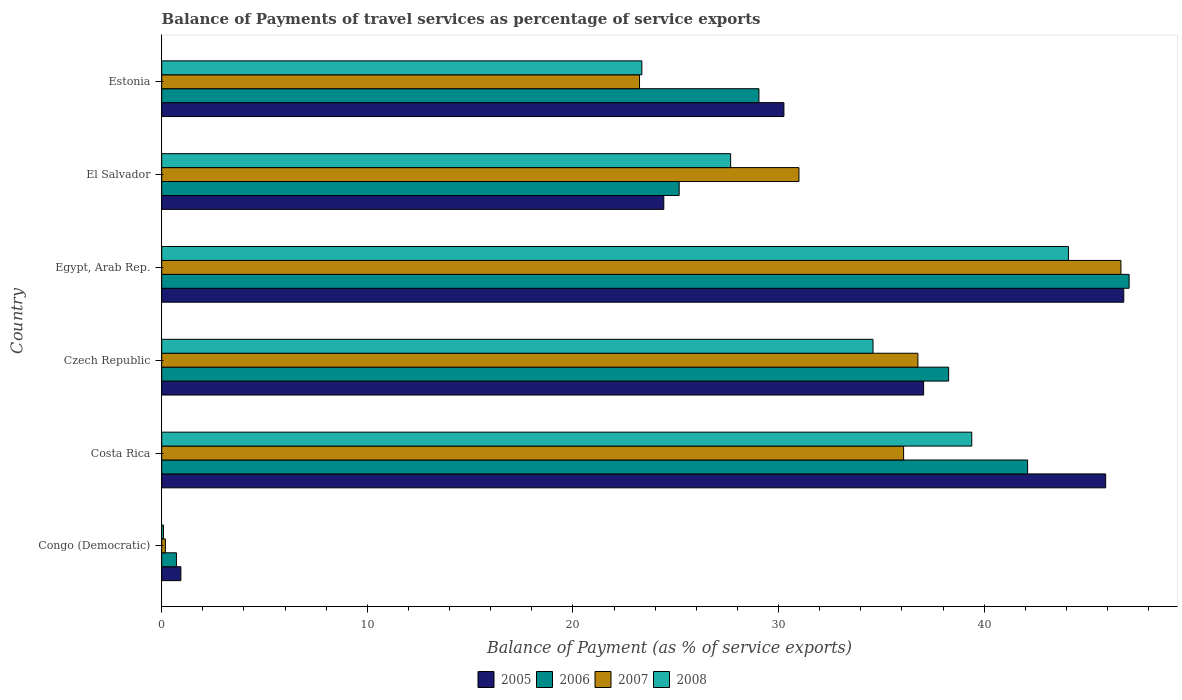How many groups of bars are there?
Provide a short and direct response. 6. Are the number of bars on each tick of the Y-axis equal?
Offer a very short reply. Yes. How many bars are there on the 2nd tick from the bottom?
Provide a succinct answer. 4. What is the label of the 2nd group of bars from the top?
Ensure brevity in your answer.  El Salvador. In how many cases, is the number of bars for a given country not equal to the number of legend labels?
Offer a terse response. 0. What is the balance of payments of travel services in 2006 in El Salvador?
Offer a very short reply. 25.17. Across all countries, what is the maximum balance of payments of travel services in 2006?
Give a very brief answer. 47.05. Across all countries, what is the minimum balance of payments of travel services in 2006?
Provide a short and direct response. 0.72. In which country was the balance of payments of travel services in 2005 maximum?
Make the answer very short. Egypt, Arab Rep. In which country was the balance of payments of travel services in 2008 minimum?
Keep it short and to the point. Congo (Democratic). What is the total balance of payments of travel services in 2005 in the graph?
Keep it short and to the point. 185.35. What is the difference between the balance of payments of travel services in 2005 in Czech Republic and that in Egypt, Arab Rep.?
Ensure brevity in your answer.  -9.73. What is the difference between the balance of payments of travel services in 2006 in Czech Republic and the balance of payments of travel services in 2008 in Congo (Democratic)?
Make the answer very short. 38.18. What is the average balance of payments of travel services in 2008 per country?
Provide a succinct answer. 28.2. What is the difference between the balance of payments of travel services in 2008 and balance of payments of travel services in 2005 in Costa Rica?
Give a very brief answer. -6.51. What is the ratio of the balance of payments of travel services in 2005 in Czech Republic to that in El Salvador?
Your answer should be compact. 1.52. Is the balance of payments of travel services in 2007 in Congo (Democratic) less than that in Czech Republic?
Your response must be concise. Yes. Is the difference between the balance of payments of travel services in 2008 in Congo (Democratic) and Egypt, Arab Rep. greater than the difference between the balance of payments of travel services in 2005 in Congo (Democratic) and Egypt, Arab Rep.?
Ensure brevity in your answer.  Yes. What is the difference between the highest and the second highest balance of payments of travel services in 2008?
Your answer should be compact. 4.7. What is the difference between the highest and the lowest balance of payments of travel services in 2008?
Your answer should be very brief. 44.01. Is it the case that in every country, the sum of the balance of payments of travel services in 2006 and balance of payments of travel services in 2007 is greater than the balance of payments of travel services in 2005?
Your answer should be very brief. No. How many countries are there in the graph?
Keep it short and to the point. 6. What is the difference between two consecutive major ticks on the X-axis?
Offer a very short reply. 10. Are the values on the major ticks of X-axis written in scientific E-notation?
Provide a succinct answer. No. Does the graph contain any zero values?
Make the answer very short. No. What is the title of the graph?
Ensure brevity in your answer.  Balance of Payments of travel services as percentage of service exports. Does "1972" appear as one of the legend labels in the graph?
Provide a succinct answer. No. What is the label or title of the X-axis?
Offer a very short reply. Balance of Payment (as % of service exports). What is the label or title of the Y-axis?
Ensure brevity in your answer.  Country. What is the Balance of Payment (as % of service exports) in 2005 in Congo (Democratic)?
Offer a very short reply. 0.93. What is the Balance of Payment (as % of service exports) in 2006 in Congo (Democratic)?
Your response must be concise. 0.72. What is the Balance of Payment (as % of service exports) in 2007 in Congo (Democratic)?
Your answer should be very brief. 0.18. What is the Balance of Payment (as % of service exports) of 2008 in Congo (Democratic)?
Provide a short and direct response. 0.08. What is the Balance of Payment (as % of service exports) in 2005 in Costa Rica?
Your answer should be compact. 45.91. What is the Balance of Payment (as % of service exports) in 2006 in Costa Rica?
Your answer should be compact. 42.11. What is the Balance of Payment (as % of service exports) of 2007 in Costa Rica?
Offer a terse response. 36.08. What is the Balance of Payment (as % of service exports) of 2008 in Costa Rica?
Give a very brief answer. 39.39. What is the Balance of Payment (as % of service exports) in 2005 in Czech Republic?
Offer a very short reply. 37.05. What is the Balance of Payment (as % of service exports) of 2006 in Czech Republic?
Offer a terse response. 38.27. What is the Balance of Payment (as % of service exports) of 2007 in Czech Republic?
Your answer should be very brief. 36.77. What is the Balance of Payment (as % of service exports) of 2008 in Czech Republic?
Provide a succinct answer. 34.59. What is the Balance of Payment (as % of service exports) of 2005 in Egypt, Arab Rep.?
Provide a succinct answer. 46.79. What is the Balance of Payment (as % of service exports) in 2006 in Egypt, Arab Rep.?
Your answer should be compact. 47.05. What is the Balance of Payment (as % of service exports) of 2007 in Egypt, Arab Rep.?
Give a very brief answer. 46.65. What is the Balance of Payment (as % of service exports) of 2008 in Egypt, Arab Rep.?
Your response must be concise. 44.09. What is the Balance of Payment (as % of service exports) in 2005 in El Salvador?
Offer a terse response. 24.42. What is the Balance of Payment (as % of service exports) of 2006 in El Salvador?
Offer a very short reply. 25.17. What is the Balance of Payment (as % of service exports) in 2007 in El Salvador?
Your answer should be compact. 30.99. What is the Balance of Payment (as % of service exports) in 2008 in El Salvador?
Your answer should be compact. 27.67. What is the Balance of Payment (as % of service exports) of 2005 in Estonia?
Give a very brief answer. 30.26. What is the Balance of Payment (as % of service exports) of 2006 in Estonia?
Give a very brief answer. 29.04. What is the Balance of Payment (as % of service exports) in 2007 in Estonia?
Your response must be concise. 23.24. What is the Balance of Payment (as % of service exports) in 2008 in Estonia?
Make the answer very short. 23.35. Across all countries, what is the maximum Balance of Payment (as % of service exports) of 2005?
Offer a very short reply. 46.79. Across all countries, what is the maximum Balance of Payment (as % of service exports) in 2006?
Your response must be concise. 47.05. Across all countries, what is the maximum Balance of Payment (as % of service exports) in 2007?
Make the answer very short. 46.65. Across all countries, what is the maximum Balance of Payment (as % of service exports) of 2008?
Keep it short and to the point. 44.09. Across all countries, what is the minimum Balance of Payment (as % of service exports) of 2005?
Give a very brief answer. 0.93. Across all countries, what is the minimum Balance of Payment (as % of service exports) in 2006?
Offer a very short reply. 0.72. Across all countries, what is the minimum Balance of Payment (as % of service exports) of 2007?
Provide a succinct answer. 0.18. Across all countries, what is the minimum Balance of Payment (as % of service exports) of 2008?
Provide a succinct answer. 0.08. What is the total Balance of Payment (as % of service exports) in 2005 in the graph?
Ensure brevity in your answer.  185.35. What is the total Balance of Payment (as % of service exports) of 2006 in the graph?
Keep it short and to the point. 182.35. What is the total Balance of Payment (as % of service exports) in 2007 in the graph?
Keep it short and to the point. 173.91. What is the total Balance of Payment (as % of service exports) of 2008 in the graph?
Offer a terse response. 169.18. What is the difference between the Balance of Payment (as % of service exports) in 2005 in Congo (Democratic) and that in Costa Rica?
Ensure brevity in your answer.  -44.97. What is the difference between the Balance of Payment (as % of service exports) of 2006 in Congo (Democratic) and that in Costa Rica?
Provide a succinct answer. -41.4. What is the difference between the Balance of Payment (as % of service exports) in 2007 in Congo (Democratic) and that in Costa Rica?
Ensure brevity in your answer.  -35.9. What is the difference between the Balance of Payment (as % of service exports) in 2008 in Congo (Democratic) and that in Costa Rica?
Ensure brevity in your answer.  -39.31. What is the difference between the Balance of Payment (as % of service exports) in 2005 in Congo (Democratic) and that in Czech Republic?
Your response must be concise. -36.12. What is the difference between the Balance of Payment (as % of service exports) of 2006 in Congo (Democratic) and that in Czech Republic?
Your response must be concise. -37.55. What is the difference between the Balance of Payment (as % of service exports) in 2007 in Congo (Democratic) and that in Czech Republic?
Provide a succinct answer. -36.6. What is the difference between the Balance of Payment (as % of service exports) in 2008 in Congo (Democratic) and that in Czech Republic?
Offer a terse response. -34.51. What is the difference between the Balance of Payment (as % of service exports) in 2005 in Congo (Democratic) and that in Egypt, Arab Rep.?
Offer a very short reply. -45.85. What is the difference between the Balance of Payment (as % of service exports) in 2006 in Congo (Democratic) and that in Egypt, Arab Rep.?
Make the answer very short. -46.33. What is the difference between the Balance of Payment (as % of service exports) in 2007 in Congo (Democratic) and that in Egypt, Arab Rep.?
Ensure brevity in your answer.  -46.47. What is the difference between the Balance of Payment (as % of service exports) in 2008 in Congo (Democratic) and that in Egypt, Arab Rep.?
Provide a succinct answer. -44.01. What is the difference between the Balance of Payment (as % of service exports) of 2005 in Congo (Democratic) and that in El Salvador?
Ensure brevity in your answer.  -23.49. What is the difference between the Balance of Payment (as % of service exports) in 2006 in Congo (Democratic) and that in El Salvador?
Offer a very short reply. -24.45. What is the difference between the Balance of Payment (as % of service exports) of 2007 in Congo (Democratic) and that in El Salvador?
Ensure brevity in your answer.  -30.81. What is the difference between the Balance of Payment (as % of service exports) in 2008 in Congo (Democratic) and that in El Salvador?
Offer a terse response. -27.58. What is the difference between the Balance of Payment (as % of service exports) in 2005 in Congo (Democratic) and that in Estonia?
Give a very brief answer. -29.33. What is the difference between the Balance of Payment (as % of service exports) in 2006 in Congo (Democratic) and that in Estonia?
Offer a very short reply. -28.33. What is the difference between the Balance of Payment (as % of service exports) of 2007 in Congo (Democratic) and that in Estonia?
Give a very brief answer. -23.06. What is the difference between the Balance of Payment (as % of service exports) in 2008 in Congo (Democratic) and that in Estonia?
Make the answer very short. -23.27. What is the difference between the Balance of Payment (as % of service exports) in 2005 in Costa Rica and that in Czech Republic?
Your answer should be compact. 8.85. What is the difference between the Balance of Payment (as % of service exports) in 2006 in Costa Rica and that in Czech Republic?
Your answer should be very brief. 3.84. What is the difference between the Balance of Payment (as % of service exports) in 2007 in Costa Rica and that in Czech Republic?
Ensure brevity in your answer.  -0.69. What is the difference between the Balance of Payment (as % of service exports) of 2008 in Costa Rica and that in Czech Republic?
Offer a terse response. 4.8. What is the difference between the Balance of Payment (as % of service exports) of 2005 in Costa Rica and that in Egypt, Arab Rep.?
Your answer should be compact. -0.88. What is the difference between the Balance of Payment (as % of service exports) in 2006 in Costa Rica and that in Egypt, Arab Rep.?
Provide a short and direct response. -4.94. What is the difference between the Balance of Payment (as % of service exports) of 2007 in Costa Rica and that in Egypt, Arab Rep.?
Make the answer very short. -10.57. What is the difference between the Balance of Payment (as % of service exports) of 2008 in Costa Rica and that in Egypt, Arab Rep.?
Provide a succinct answer. -4.7. What is the difference between the Balance of Payment (as % of service exports) of 2005 in Costa Rica and that in El Salvador?
Make the answer very short. 21.49. What is the difference between the Balance of Payment (as % of service exports) in 2006 in Costa Rica and that in El Salvador?
Provide a succinct answer. 16.95. What is the difference between the Balance of Payment (as % of service exports) in 2007 in Costa Rica and that in El Salvador?
Your answer should be compact. 5.09. What is the difference between the Balance of Payment (as % of service exports) in 2008 in Costa Rica and that in El Salvador?
Give a very brief answer. 11.73. What is the difference between the Balance of Payment (as % of service exports) of 2005 in Costa Rica and that in Estonia?
Your answer should be very brief. 15.65. What is the difference between the Balance of Payment (as % of service exports) of 2006 in Costa Rica and that in Estonia?
Provide a succinct answer. 13.07. What is the difference between the Balance of Payment (as % of service exports) in 2007 in Costa Rica and that in Estonia?
Offer a very short reply. 12.84. What is the difference between the Balance of Payment (as % of service exports) in 2008 in Costa Rica and that in Estonia?
Your response must be concise. 16.04. What is the difference between the Balance of Payment (as % of service exports) of 2005 in Czech Republic and that in Egypt, Arab Rep.?
Your answer should be very brief. -9.73. What is the difference between the Balance of Payment (as % of service exports) of 2006 in Czech Republic and that in Egypt, Arab Rep.?
Give a very brief answer. -8.78. What is the difference between the Balance of Payment (as % of service exports) in 2007 in Czech Republic and that in Egypt, Arab Rep.?
Make the answer very short. -9.87. What is the difference between the Balance of Payment (as % of service exports) in 2008 in Czech Republic and that in Egypt, Arab Rep.?
Your answer should be very brief. -9.5. What is the difference between the Balance of Payment (as % of service exports) of 2005 in Czech Republic and that in El Salvador?
Provide a succinct answer. 12.64. What is the difference between the Balance of Payment (as % of service exports) of 2006 in Czech Republic and that in El Salvador?
Your response must be concise. 13.1. What is the difference between the Balance of Payment (as % of service exports) of 2007 in Czech Republic and that in El Salvador?
Ensure brevity in your answer.  5.78. What is the difference between the Balance of Payment (as % of service exports) in 2008 in Czech Republic and that in El Salvador?
Make the answer very short. 6.92. What is the difference between the Balance of Payment (as % of service exports) in 2005 in Czech Republic and that in Estonia?
Offer a very short reply. 6.8. What is the difference between the Balance of Payment (as % of service exports) of 2006 in Czech Republic and that in Estonia?
Keep it short and to the point. 9.23. What is the difference between the Balance of Payment (as % of service exports) in 2007 in Czech Republic and that in Estonia?
Your answer should be compact. 13.54. What is the difference between the Balance of Payment (as % of service exports) in 2008 in Czech Republic and that in Estonia?
Keep it short and to the point. 11.24. What is the difference between the Balance of Payment (as % of service exports) of 2005 in Egypt, Arab Rep. and that in El Salvador?
Provide a succinct answer. 22.37. What is the difference between the Balance of Payment (as % of service exports) of 2006 in Egypt, Arab Rep. and that in El Salvador?
Keep it short and to the point. 21.88. What is the difference between the Balance of Payment (as % of service exports) of 2007 in Egypt, Arab Rep. and that in El Salvador?
Your answer should be very brief. 15.66. What is the difference between the Balance of Payment (as % of service exports) of 2008 in Egypt, Arab Rep. and that in El Salvador?
Give a very brief answer. 16.43. What is the difference between the Balance of Payment (as % of service exports) in 2005 in Egypt, Arab Rep. and that in Estonia?
Offer a very short reply. 16.53. What is the difference between the Balance of Payment (as % of service exports) of 2006 in Egypt, Arab Rep. and that in Estonia?
Your answer should be very brief. 18. What is the difference between the Balance of Payment (as % of service exports) of 2007 in Egypt, Arab Rep. and that in Estonia?
Give a very brief answer. 23.41. What is the difference between the Balance of Payment (as % of service exports) of 2008 in Egypt, Arab Rep. and that in Estonia?
Your answer should be compact. 20.74. What is the difference between the Balance of Payment (as % of service exports) in 2005 in El Salvador and that in Estonia?
Your response must be concise. -5.84. What is the difference between the Balance of Payment (as % of service exports) of 2006 in El Salvador and that in Estonia?
Provide a succinct answer. -3.88. What is the difference between the Balance of Payment (as % of service exports) in 2007 in El Salvador and that in Estonia?
Offer a very short reply. 7.75. What is the difference between the Balance of Payment (as % of service exports) of 2008 in El Salvador and that in Estonia?
Provide a short and direct response. 4.32. What is the difference between the Balance of Payment (as % of service exports) in 2005 in Congo (Democratic) and the Balance of Payment (as % of service exports) in 2006 in Costa Rica?
Your answer should be very brief. -41.18. What is the difference between the Balance of Payment (as % of service exports) of 2005 in Congo (Democratic) and the Balance of Payment (as % of service exports) of 2007 in Costa Rica?
Provide a short and direct response. -35.15. What is the difference between the Balance of Payment (as % of service exports) of 2005 in Congo (Democratic) and the Balance of Payment (as % of service exports) of 2008 in Costa Rica?
Offer a terse response. -38.46. What is the difference between the Balance of Payment (as % of service exports) of 2006 in Congo (Democratic) and the Balance of Payment (as % of service exports) of 2007 in Costa Rica?
Provide a succinct answer. -35.36. What is the difference between the Balance of Payment (as % of service exports) in 2006 in Congo (Democratic) and the Balance of Payment (as % of service exports) in 2008 in Costa Rica?
Your answer should be compact. -38.68. What is the difference between the Balance of Payment (as % of service exports) of 2007 in Congo (Democratic) and the Balance of Payment (as % of service exports) of 2008 in Costa Rica?
Make the answer very short. -39.22. What is the difference between the Balance of Payment (as % of service exports) of 2005 in Congo (Democratic) and the Balance of Payment (as % of service exports) of 2006 in Czech Republic?
Offer a very short reply. -37.34. What is the difference between the Balance of Payment (as % of service exports) in 2005 in Congo (Democratic) and the Balance of Payment (as % of service exports) in 2007 in Czech Republic?
Make the answer very short. -35.84. What is the difference between the Balance of Payment (as % of service exports) in 2005 in Congo (Democratic) and the Balance of Payment (as % of service exports) in 2008 in Czech Republic?
Offer a terse response. -33.66. What is the difference between the Balance of Payment (as % of service exports) in 2006 in Congo (Democratic) and the Balance of Payment (as % of service exports) in 2007 in Czech Republic?
Offer a very short reply. -36.06. What is the difference between the Balance of Payment (as % of service exports) of 2006 in Congo (Democratic) and the Balance of Payment (as % of service exports) of 2008 in Czech Republic?
Offer a terse response. -33.88. What is the difference between the Balance of Payment (as % of service exports) of 2007 in Congo (Democratic) and the Balance of Payment (as % of service exports) of 2008 in Czech Republic?
Offer a very short reply. -34.41. What is the difference between the Balance of Payment (as % of service exports) in 2005 in Congo (Democratic) and the Balance of Payment (as % of service exports) in 2006 in Egypt, Arab Rep.?
Provide a succinct answer. -46.11. What is the difference between the Balance of Payment (as % of service exports) of 2005 in Congo (Democratic) and the Balance of Payment (as % of service exports) of 2007 in Egypt, Arab Rep.?
Provide a succinct answer. -45.72. What is the difference between the Balance of Payment (as % of service exports) in 2005 in Congo (Democratic) and the Balance of Payment (as % of service exports) in 2008 in Egypt, Arab Rep.?
Give a very brief answer. -43.16. What is the difference between the Balance of Payment (as % of service exports) in 2006 in Congo (Democratic) and the Balance of Payment (as % of service exports) in 2007 in Egypt, Arab Rep.?
Offer a very short reply. -45.93. What is the difference between the Balance of Payment (as % of service exports) in 2006 in Congo (Democratic) and the Balance of Payment (as % of service exports) in 2008 in Egypt, Arab Rep.?
Make the answer very short. -43.38. What is the difference between the Balance of Payment (as % of service exports) in 2007 in Congo (Democratic) and the Balance of Payment (as % of service exports) in 2008 in Egypt, Arab Rep.?
Provide a short and direct response. -43.92. What is the difference between the Balance of Payment (as % of service exports) in 2005 in Congo (Democratic) and the Balance of Payment (as % of service exports) in 2006 in El Salvador?
Keep it short and to the point. -24.23. What is the difference between the Balance of Payment (as % of service exports) of 2005 in Congo (Democratic) and the Balance of Payment (as % of service exports) of 2007 in El Salvador?
Provide a short and direct response. -30.06. What is the difference between the Balance of Payment (as % of service exports) in 2005 in Congo (Democratic) and the Balance of Payment (as % of service exports) in 2008 in El Salvador?
Offer a very short reply. -26.74. What is the difference between the Balance of Payment (as % of service exports) in 2006 in Congo (Democratic) and the Balance of Payment (as % of service exports) in 2007 in El Salvador?
Offer a very short reply. -30.27. What is the difference between the Balance of Payment (as % of service exports) of 2006 in Congo (Democratic) and the Balance of Payment (as % of service exports) of 2008 in El Salvador?
Make the answer very short. -26.95. What is the difference between the Balance of Payment (as % of service exports) in 2007 in Congo (Democratic) and the Balance of Payment (as % of service exports) in 2008 in El Salvador?
Provide a succinct answer. -27.49. What is the difference between the Balance of Payment (as % of service exports) in 2005 in Congo (Democratic) and the Balance of Payment (as % of service exports) in 2006 in Estonia?
Provide a short and direct response. -28.11. What is the difference between the Balance of Payment (as % of service exports) of 2005 in Congo (Democratic) and the Balance of Payment (as % of service exports) of 2007 in Estonia?
Make the answer very short. -22.3. What is the difference between the Balance of Payment (as % of service exports) of 2005 in Congo (Democratic) and the Balance of Payment (as % of service exports) of 2008 in Estonia?
Provide a succinct answer. -22.42. What is the difference between the Balance of Payment (as % of service exports) of 2006 in Congo (Democratic) and the Balance of Payment (as % of service exports) of 2007 in Estonia?
Offer a very short reply. -22.52. What is the difference between the Balance of Payment (as % of service exports) of 2006 in Congo (Democratic) and the Balance of Payment (as % of service exports) of 2008 in Estonia?
Your answer should be very brief. -22.63. What is the difference between the Balance of Payment (as % of service exports) in 2007 in Congo (Democratic) and the Balance of Payment (as % of service exports) in 2008 in Estonia?
Keep it short and to the point. -23.17. What is the difference between the Balance of Payment (as % of service exports) in 2005 in Costa Rica and the Balance of Payment (as % of service exports) in 2006 in Czech Republic?
Offer a very short reply. 7.64. What is the difference between the Balance of Payment (as % of service exports) in 2005 in Costa Rica and the Balance of Payment (as % of service exports) in 2007 in Czech Republic?
Offer a terse response. 9.13. What is the difference between the Balance of Payment (as % of service exports) of 2005 in Costa Rica and the Balance of Payment (as % of service exports) of 2008 in Czech Republic?
Make the answer very short. 11.31. What is the difference between the Balance of Payment (as % of service exports) in 2006 in Costa Rica and the Balance of Payment (as % of service exports) in 2007 in Czech Republic?
Your answer should be very brief. 5.34. What is the difference between the Balance of Payment (as % of service exports) in 2006 in Costa Rica and the Balance of Payment (as % of service exports) in 2008 in Czech Republic?
Your answer should be compact. 7.52. What is the difference between the Balance of Payment (as % of service exports) in 2007 in Costa Rica and the Balance of Payment (as % of service exports) in 2008 in Czech Republic?
Give a very brief answer. 1.49. What is the difference between the Balance of Payment (as % of service exports) in 2005 in Costa Rica and the Balance of Payment (as % of service exports) in 2006 in Egypt, Arab Rep.?
Provide a short and direct response. -1.14. What is the difference between the Balance of Payment (as % of service exports) of 2005 in Costa Rica and the Balance of Payment (as % of service exports) of 2007 in Egypt, Arab Rep.?
Make the answer very short. -0.74. What is the difference between the Balance of Payment (as % of service exports) in 2005 in Costa Rica and the Balance of Payment (as % of service exports) in 2008 in Egypt, Arab Rep.?
Make the answer very short. 1.81. What is the difference between the Balance of Payment (as % of service exports) in 2006 in Costa Rica and the Balance of Payment (as % of service exports) in 2007 in Egypt, Arab Rep.?
Your answer should be very brief. -4.54. What is the difference between the Balance of Payment (as % of service exports) of 2006 in Costa Rica and the Balance of Payment (as % of service exports) of 2008 in Egypt, Arab Rep.?
Make the answer very short. -1.98. What is the difference between the Balance of Payment (as % of service exports) of 2007 in Costa Rica and the Balance of Payment (as % of service exports) of 2008 in Egypt, Arab Rep.?
Your answer should be compact. -8.01. What is the difference between the Balance of Payment (as % of service exports) of 2005 in Costa Rica and the Balance of Payment (as % of service exports) of 2006 in El Salvador?
Offer a very short reply. 20.74. What is the difference between the Balance of Payment (as % of service exports) in 2005 in Costa Rica and the Balance of Payment (as % of service exports) in 2007 in El Salvador?
Provide a short and direct response. 14.92. What is the difference between the Balance of Payment (as % of service exports) of 2005 in Costa Rica and the Balance of Payment (as % of service exports) of 2008 in El Salvador?
Your response must be concise. 18.24. What is the difference between the Balance of Payment (as % of service exports) in 2006 in Costa Rica and the Balance of Payment (as % of service exports) in 2007 in El Salvador?
Keep it short and to the point. 11.12. What is the difference between the Balance of Payment (as % of service exports) of 2006 in Costa Rica and the Balance of Payment (as % of service exports) of 2008 in El Salvador?
Offer a terse response. 14.44. What is the difference between the Balance of Payment (as % of service exports) of 2007 in Costa Rica and the Balance of Payment (as % of service exports) of 2008 in El Salvador?
Keep it short and to the point. 8.41. What is the difference between the Balance of Payment (as % of service exports) in 2005 in Costa Rica and the Balance of Payment (as % of service exports) in 2006 in Estonia?
Your answer should be very brief. 16.86. What is the difference between the Balance of Payment (as % of service exports) in 2005 in Costa Rica and the Balance of Payment (as % of service exports) in 2007 in Estonia?
Your response must be concise. 22.67. What is the difference between the Balance of Payment (as % of service exports) of 2005 in Costa Rica and the Balance of Payment (as % of service exports) of 2008 in Estonia?
Your answer should be very brief. 22.56. What is the difference between the Balance of Payment (as % of service exports) in 2006 in Costa Rica and the Balance of Payment (as % of service exports) in 2007 in Estonia?
Ensure brevity in your answer.  18.87. What is the difference between the Balance of Payment (as % of service exports) in 2006 in Costa Rica and the Balance of Payment (as % of service exports) in 2008 in Estonia?
Your answer should be compact. 18.76. What is the difference between the Balance of Payment (as % of service exports) in 2007 in Costa Rica and the Balance of Payment (as % of service exports) in 2008 in Estonia?
Your answer should be compact. 12.73. What is the difference between the Balance of Payment (as % of service exports) in 2005 in Czech Republic and the Balance of Payment (as % of service exports) in 2006 in Egypt, Arab Rep.?
Give a very brief answer. -9.99. What is the difference between the Balance of Payment (as % of service exports) of 2005 in Czech Republic and the Balance of Payment (as % of service exports) of 2007 in Egypt, Arab Rep.?
Provide a succinct answer. -9.59. What is the difference between the Balance of Payment (as % of service exports) in 2005 in Czech Republic and the Balance of Payment (as % of service exports) in 2008 in Egypt, Arab Rep.?
Offer a very short reply. -7.04. What is the difference between the Balance of Payment (as % of service exports) of 2006 in Czech Republic and the Balance of Payment (as % of service exports) of 2007 in Egypt, Arab Rep.?
Ensure brevity in your answer.  -8.38. What is the difference between the Balance of Payment (as % of service exports) in 2006 in Czech Republic and the Balance of Payment (as % of service exports) in 2008 in Egypt, Arab Rep.?
Make the answer very short. -5.83. What is the difference between the Balance of Payment (as % of service exports) of 2007 in Czech Republic and the Balance of Payment (as % of service exports) of 2008 in Egypt, Arab Rep.?
Offer a terse response. -7.32. What is the difference between the Balance of Payment (as % of service exports) of 2005 in Czech Republic and the Balance of Payment (as % of service exports) of 2006 in El Salvador?
Ensure brevity in your answer.  11.89. What is the difference between the Balance of Payment (as % of service exports) in 2005 in Czech Republic and the Balance of Payment (as % of service exports) in 2007 in El Salvador?
Provide a short and direct response. 6.06. What is the difference between the Balance of Payment (as % of service exports) of 2005 in Czech Republic and the Balance of Payment (as % of service exports) of 2008 in El Salvador?
Provide a short and direct response. 9.39. What is the difference between the Balance of Payment (as % of service exports) of 2006 in Czech Republic and the Balance of Payment (as % of service exports) of 2007 in El Salvador?
Your response must be concise. 7.28. What is the difference between the Balance of Payment (as % of service exports) of 2006 in Czech Republic and the Balance of Payment (as % of service exports) of 2008 in El Salvador?
Your answer should be very brief. 10.6. What is the difference between the Balance of Payment (as % of service exports) in 2007 in Czech Republic and the Balance of Payment (as % of service exports) in 2008 in El Salvador?
Provide a short and direct response. 9.11. What is the difference between the Balance of Payment (as % of service exports) of 2005 in Czech Republic and the Balance of Payment (as % of service exports) of 2006 in Estonia?
Offer a very short reply. 8.01. What is the difference between the Balance of Payment (as % of service exports) in 2005 in Czech Republic and the Balance of Payment (as % of service exports) in 2007 in Estonia?
Offer a very short reply. 13.82. What is the difference between the Balance of Payment (as % of service exports) of 2005 in Czech Republic and the Balance of Payment (as % of service exports) of 2008 in Estonia?
Provide a succinct answer. 13.7. What is the difference between the Balance of Payment (as % of service exports) in 2006 in Czech Republic and the Balance of Payment (as % of service exports) in 2007 in Estonia?
Offer a very short reply. 15.03. What is the difference between the Balance of Payment (as % of service exports) in 2006 in Czech Republic and the Balance of Payment (as % of service exports) in 2008 in Estonia?
Provide a succinct answer. 14.92. What is the difference between the Balance of Payment (as % of service exports) of 2007 in Czech Republic and the Balance of Payment (as % of service exports) of 2008 in Estonia?
Offer a very short reply. 13.42. What is the difference between the Balance of Payment (as % of service exports) of 2005 in Egypt, Arab Rep. and the Balance of Payment (as % of service exports) of 2006 in El Salvador?
Provide a short and direct response. 21.62. What is the difference between the Balance of Payment (as % of service exports) in 2005 in Egypt, Arab Rep. and the Balance of Payment (as % of service exports) in 2007 in El Salvador?
Give a very brief answer. 15.8. What is the difference between the Balance of Payment (as % of service exports) in 2005 in Egypt, Arab Rep. and the Balance of Payment (as % of service exports) in 2008 in El Salvador?
Give a very brief answer. 19.12. What is the difference between the Balance of Payment (as % of service exports) in 2006 in Egypt, Arab Rep. and the Balance of Payment (as % of service exports) in 2007 in El Salvador?
Provide a short and direct response. 16.06. What is the difference between the Balance of Payment (as % of service exports) of 2006 in Egypt, Arab Rep. and the Balance of Payment (as % of service exports) of 2008 in El Salvador?
Keep it short and to the point. 19.38. What is the difference between the Balance of Payment (as % of service exports) of 2007 in Egypt, Arab Rep. and the Balance of Payment (as % of service exports) of 2008 in El Salvador?
Your response must be concise. 18.98. What is the difference between the Balance of Payment (as % of service exports) of 2005 in Egypt, Arab Rep. and the Balance of Payment (as % of service exports) of 2006 in Estonia?
Ensure brevity in your answer.  17.74. What is the difference between the Balance of Payment (as % of service exports) of 2005 in Egypt, Arab Rep. and the Balance of Payment (as % of service exports) of 2007 in Estonia?
Make the answer very short. 23.55. What is the difference between the Balance of Payment (as % of service exports) of 2005 in Egypt, Arab Rep. and the Balance of Payment (as % of service exports) of 2008 in Estonia?
Your answer should be compact. 23.43. What is the difference between the Balance of Payment (as % of service exports) of 2006 in Egypt, Arab Rep. and the Balance of Payment (as % of service exports) of 2007 in Estonia?
Provide a short and direct response. 23.81. What is the difference between the Balance of Payment (as % of service exports) in 2006 in Egypt, Arab Rep. and the Balance of Payment (as % of service exports) in 2008 in Estonia?
Provide a short and direct response. 23.7. What is the difference between the Balance of Payment (as % of service exports) of 2007 in Egypt, Arab Rep. and the Balance of Payment (as % of service exports) of 2008 in Estonia?
Provide a short and direct response. 23.3. What is the difference between the Balance of Payment (as % of service exports) in 2005 in El Salvador and the Balance of Payment (as % of service exports) in 2006 in Estonia?
Provide a succinct answer. -4.63. What is the difference between the Balance of Payment (as % of service exports) of 2005 in El Salvador and the Balance of Payment (as % of service exports) of 2007 in Estonia?
Give a very brief answer. 1.18. What is the difference between the Balance of Payment (as % of service exports) of 2005 in El Salvador and the Balance of Payment (as % of service exports) of 2008 in Estonia?
Keep it short and to the point. 1.07. What is the difference between the Balance of Payment (as % of service exports) of 2006 in El Salvador and the Balance of Payment (as % of service exports) of 2007 in Estonia?
Ensure brevity in your answer.  1.93. What is the difference between the Balance of Payment (as % of service exports) in 2006 in El Salvador and the Balance of Payment (as % of service exports) in 2008 in Estonia?
Your answer should be very brief. 1.81. What is the difference between the Balance of Payment (as % of service exports) of 2007 in El Salvador and the Balance of Payment (as % of service exports) of 2008 in Estonia?
Offer a terse response. 7.64. What is the average Balance of Payment (as % of service exports) in 2005 per country?
Provide a short and direct response. 30.89. What is the average Balance of Payment (as % of service exports) of 2006 per country?
Keep it short and to the point. 30.39. What is the average Balance of Payment (as % of service exports) of 2007 per country?
Your response must be concise. 28.98. What is the average Balance of Payment (as % of service exports) in 2008 per country?
Provide a succinct answer. 28.2. What is the difference between the Balance of Payment (as % of service exports) in 2005 and Balance of Payment (as % of service exports) in 2006 in Congo (Democratic)?
Your answer should be compact. 0.22. What is the difference between the Balance of Payment (as % of service exports) in 2005 and Balance of Payment (as % of service exports) in 2007 in Congo (Democratic)?
Your answer should be very brief. 0.75. What is the difference between the Balance of Payment (as % of service exports) of 2005 and Balance of Payment (as % of service exports) of 2008 in Congo (Democratic)?
Your response must be concise. 0.85. What is the difference between the Balance of Payment (as % of service exports) in 2006 and Balance of Payment (as % of service exports) in 2007 in Congo (Democratic)?
Offer a very short reply. 0.54. What is the difference between the Balance of Payment (as % of service exports) in 2006 and Balance of Payment (as % of service exports) in 2008 in Congo (Democratic)?
Your answer should be compact. 0.63. What is the difference between the Balance of Payment (as % of service exports) of 2007 and Balance of Payment (as % of service exports) of 2008 in Congo (Democratic)?
Your response must be concise. 0.09. What is the difference between the Balance of Payment (as % of service exports) in 2005 and Balance of Payment (as % of service exports) in 2006 in Costa Rica?
Your answer should be compact. 3.8. What is the difference between the Balance of Payment (as % of service exports) in 2005 and Balance of Payment (as % of service exports) in 2007 in Costa Rica?
Ensure brevity in your answer.  9.83. What is the difference between the Balance of Payment (as % of service exports) in 2005 and Balance of Payment (as % of service exports) in 2008 in Costa Rica?
Provide a succinct answer. 6.51. What is the difference between the Balance of Payment (as % of service exports) in 2006 and Balance of Payment (as % of service exports) in 2007 in Costa Rica?
Give a very brief answer. 6.03. What is the difference between the Balance of Payment (as % of service exports) of 2006 and Balance of Payment (as % of service exports) of 2008 in Costa Rica?
Keep it short and to the point. 2.72. What is the difference between the Balance of Payment (as % of service exports) of 2007 and Balance of Payment (as % of service exports) of 2008 in Costa Rica?
Keep it short and to the point. -3.31. What is the difference between the Balance of Payment (as % of service exports) in 2005 and Balance of Payment (as % of service exports) in 2006 in Czech Republic?
Offer a very short reply. -1.22. What is the difference between the Balance of Payment (as % of service exports) of 2005 and Balance of Payment (as % of service exports) of 2007 in Czech Republic?
Ensure brevity in your answer.  0.28. What is the difference between the Balance of Payment (as % of service exports) in 2005 and Balance of Payment (as % of service exports) in 2008 in Czech Republic?
Give a very brief answer. 2.46. What is the difference between the Balance of Payment (as % of service exports) of 2006 and Balance of Payment (as % of service exports) of 2007 in Czech Republic?
Offer a very short reply. 1.5. What is the difference between the Balance of Payment (as % of service exports) of 2006 and Balance of Payment (as % of service exports) of 2008 in Czech Republic?
Provide a short and direct response. 3.68. What is the difference between the Balance of Payment (as % of service exports) in 2007 and Balance of Payment (as % of service exports) in 2008 in Czech Republic?
Make the answer very short. 2.18. What is the difference between the Balance of Payment (as % of service exports) in 2005 and Balance of Payment (as % of service exports) in 2006 in Egypt, Arab Rep.?
Provide a succinct answer. -0.26. What is the difference between the Balance of Payment (as % of service exports) in 2005 and Balance of Payment (as % of service exports) in 2007 in Egypt, Arab Rep.?
Offer a terse response. 0.14. What is the difference between the Balance of Payment (as % of service exports) in 2005 and Balance of Payment (as % of service exports) in 2008 in Egypt, Arab Rep.?
Give a very brief answer. 2.69. What is the difference between the Balance of Payment (as % of service exports) in 2006 and Balance of Payment (as % of service exports) in 2007 in Egypt, Arab Rep.?
Provide a short and direct response. 0.4. What is the difference between the Balance of Payment (as % of service exports) in 2006 and Balance of Payment (as % of service exports) in 2008 in Egypt, Arab Rep.?
Your answer should be very brief. 2.95. What is the difference between the Balance of Payment (as % of service exports) of 2007 and Balance of Payment (as % of service exports) of 2008 in Egypt, Arab Rep.?
Make the answer very short. 2.55. What is the difference between the Balance of Payment (as % of service exports) of 2005 and Balance of Payment (as % of service exports) of 2006 in El Salvador?
Offer a very short reply. -0.75. What is the difference between the Balance of Payment (as % of service exports) of 2005 and Balance of Payment (as % of service exports) of 2007 in El Salvador?
Provide a succinct answer. -6.57. What is the difference between the Balance of Payment (as % of service exports) in 2005 and Balance of Payment (as % of service exports) in 2008 in El Salvador?
Ensure brevity in your answer.  -3.25. What is the difference between the Balance of Payment (as % of service exports) of 2006 and Balance of Payment (as % of service exports) of 2007 in El Salvador?
Offer a very short reply. -5.82. What is the difference between the Balance of Payment (as % of service exports) of 2006 and Balance of Payment (as % of service exports) of 2008 in El Salvador?
Give a very brief answer. -2.5. What is the difference between the Balance of Payment (as % of service exports) of 2007 and Balance of Payment (as % of service exports) of 2008 in El Salvador?
Provide a short and direct response. 3.32. What is the difference between the Balance of Payment (as % of service exports) in 2005 and Balance of Payment (as % of service exports) in 2006 in Estonia?
Provide a succinct answer. 1.21. What is the difference between the Balance of Payment (as % of service exports) in 2005 and Balance of Payment (as % of service exports) in 2007 in Estonia?
Your response must be concise. 7.02. What is the difference between the Balance of Payment (as % of service exports) of 2005 and Balance of Payment (as % of service exports) of 2008 in Estonia?
Offer a terse response. 6.91. What is the difference between the Balance of Payment (as % of service exports) of 2006 and Balance of Payment (as % of service exports) of 2007 in Estonia?
Ensure brevity in your answer.  5.81. What is the difference between the Balance of Payment (as % of service exports) of 2006 and Balance of Payment (as % of service exports) of 2008 in Estonia?
Ensure brevity in your answer.  5.69. What is the difference between the Balance of Payment (as % of service exports) of 2007 and Balance of Payment (as % of service exports) of 2008 in Estonia?
Your response must be concise. -0.11. What is the ratio of the Balance of Payment (as % of service exports) of 2005 in Congo (Democratic) to that in Costa Rica?
Your response must be concise. 0.02. What is the ratio of the Balance of Payment (as % of service exports) in 2006 in Congo (Democratic) to that in Costa Rica?
Provide a short and direct response. 0.02. What is the ratio of the Balance of Payment (as % of service exports) of 2007 in Congo (Democratic) to that in Costa Rica?
Offer a very short reply. 0. What is the ratio of the Balance of Payment (as % of service exports) in 2008 in Congo (Democratic) to that in Costa Rica?
Keep it short and to the point. 0. What is the ratio of the Balance of Payment (as % of service exports) in 2005 in Congo (Democratic) to that in Czech Republic?
Your answer should be compact. 0.03. What is the ratio of the Balance of Payment (as % of service exports) of 2006 in Congo (Democratic) to that in Czech Republic?
Give a very brief answer. 0.02. What is the ratio of the Balance of Payment (as % of service exports) in 2007 in Congo (Democratic) to that in Czech Republic?
Your response must be concise. 0. What is the ratio of the Balance of Payment (as % of service exports) in 2008 in Congo (Democratic) to that in Czech Republic?
Your answer should be compact. 0. What is the ratio of the Balance of Payment (as % of service exports) in 2005 in Congo (Democratic) to that in Egypt, Arab Rep.?
Your answer should be very brief. 0.02. What is the ratio of the Balance of Payment (as % of service exports) in 2006 in Congo (Democratic) to that in Egypt, Arab Rep.?
Your answer should be compact. 0.02. What is the ratio of the Balance of Payment (as % of service exports) in 2007 in Congo (Democratic) to that in Egypt, Arab Rep.?
Provide a succinct answer. 0. What is the ratio of the Balance of Payment (as % of service exports) of 2008 in Congo (Democratic) to that in Egypt, Arab Rep.?
Ensure brevity in your answer.  0. What is the ratio of the Balance of Payment (as % of service exports) in 2005 in Congo (Democratic) to that in El Salvador?
Give a very brief answer. 0.04. What is the ratio of the Balance of Payment (as % of service exports) in 2006 in Congo (Democratic) to that in El Salvador?
Provide a short and direct response. 0.03. What is the ratio of the Balance of Payment (as % of service exports) in 2007 in Congo (Democratic) to that in El Salvador?
Offer a terse response. 0.01. What is the ratio of the Balance of Payment (as % of service exports) in 2008 in Congo (Democratic) to that in El Salvador?
Offer a very short reply. 0. What is the ratio of the Balance of Payment (as % of service exports) of 2005 in Congo (Democratic) to that in Estonia?
Your answer should be compact. 0.03. What is the ratio of the Balance of Payment (as % of service exports) in 2006 in Congo (Democratic) to that in Estonia?
Provide a succinct answer. 0.02. What is the ratio of the Balance of Payment (as % of service exports) in 2007 in Congo (Democratic) to that in Estonia?
Offer a very short reply. 0.01. What is the ratio of the Balance of Payment (as % of service exports) of 2008 in Congo (Democratic) to that in Estonia?
Keep it short and to the point. 0. What is the ratio of the Balance of Payment (as % of service exports) in 2005 in Costa Rica to that in Czech Republic?
Give a very brief answer. 1.24. What is the ratio of the Balance of Payment (as % of service exports) in 2006 in Costa Rica to that in Czech Republic?
Your answer should be compact. 1.1. What is the ratio of the Balance of Payment (as % of service exports) in 2007 in Costa Rica to that in Czech Republic?
Offer a terse response. 0.98. What is the ratio of the Balance of Payment (as % of service exports) of 2008 in Costa Rica to that in Czech Republic?
Your answer should be compact. 1.14. What is the ratio of the Balance of Payment (as % of service exports) in 2005 in Costa Rica to that in Egypt, Arab Rep.?
Give a very brief answer. 0.98. What is the ratio of the Balance of Payment (as % of service exports) of 2006 in Costa Rica to that in Egypt, Arab Rep.?
Offer a terse response. 0.9. What is the ratio of the Balance of Payment (as % of service exports) in 2007 in Costa Rica to that in Egypt, Arab Rep.?
Offer a terse response. 0.77. What is the ratio of the Balance of Payment (as % of service exports) in 2008 in Costa Rica to that in Egypt, Arab Rep.?
Keep it short and to the point. 0.89. What is the ratio of the Balance of Payment (as % of service exports) of 2005 in Costa Rica to that in El Salvador?
Provide a succinct answer. 1.88. What is the ratio of the Balance of Payment (as % of service exports) of 2006 in Costa Rica to that in El Salvador?
Make the answer very short. 1.67. What is the ratio of the Balance of Payment (as % of service exports) in 2007 in Costa Rica to that in El Salvador?
Offer a very short reply. 1.16. What is the ratio of the Balance of Payment (as % of service exports) of 2008 in Costa Rica to that in El Salvador?
Offer a terse response. 1.42. What is the ratio of the Balance of Payment (as % of service exports) in 2005 in Costa Rica to that in Estonia?
Make the answer very short. 1.52. What is the ratio of the Balance of Payment (as % of service exports) in 2006 in Costa Rica to that in Estonia?
Offer a terse response. 1.45. What is the ratio of the Balance of Payment (as % of service exports) of 2007 in Costa Rica to that in Estonia?
Offer a terse response. 1.55. What is the ratio of the Balance of Payment (as % of service exports) in 2008 in Costa Rica to that in Estonia?
Make the answer very short. 1.69. What is the ratio of the Balance of Payment (as % of service exports) in 2005 in Czech Republic to that in Egypt, Arab Rep.?
Give a very brief answer. 0.79. What is the ratio of the Balance of Payment (as % of service exports) in 2006 in Czech Republic to that in Egypt, Arab Rep.?
Your answer should be very brief. 0.81. What is the ratio of the Balance of Payment (as % of service exports) of 2007 in Czech Republic to that in Egypt, Arab Rep.?
Keep it short and to the point. 0.79. What is the ratio of the Balance of Payment (as % of service exports) of 2008 in Czech Republic to that in Egypt, Arab Rep.?
Your answer should be very brief. 0.78. What is the ratio of the Balance of Payment (as % of service exports) of 2005 in Czech Republic to that in El Salvador?
Your answer should be compact. 1.52. What is the ratio of the Balance of Payment (as % of service exports) in 2006 in Czech Republic to that in El Salvador?
Make the answer very short. 1.52. What is the ratio of the Balance of Payment (as % of service exports) of 2007 in Czech Republic to that in El Salvador?
Offer a terse response. 1.19. What is the ratio of the Balance of Payment (as % of service exports) in 2008 in Czech Republic to that in El Salvador?
Offer a terse response. 1.25. What is the ratio of the Balance of Payment (as % of service exports) in 2005 in Czech Republic to that in Estonia?
Ensure brevity in your answer.  1.22. What is the ratio of the Balance of Payment (as % of service exports) in 2006 in Czech Republic to that in Estonia?
Provide a short and direct response. 1.32. What is the ratio of the Balance of Payment (as % of service exports) in 2007 in Czech Republic to that in Estonia?
Provide a succinct answer. 1.58. What is the ratio of the Balance of Payment (as % of service exports) of 2008 in Czech Republic to that in Estonia?
Offer a very short reply. 1.48. What is the ratio of the Balance of Payment (as % of service exports) in 2005 in Egypt, Arab Rep. to that in El Salvador?
Your response must be concise. 1.92. What is the ratio of the Balance of Payment (as % of service exports) of 2006 in Egypt, Arab Rep. to that in El Salvador?
Make the answer very short. 1.87. What is the ratio of the Balance of Payment (as % of service exports) in 2007 in Egypt, Arab Rep. to that in El Salvador?
Provide a short and direct response. 1.51. What is the ratio of the Balance of Payment (as % of service exports) in 2008 in Egypt, Arab Rep. to that in El Salvador?
Make the answer very short. 1.59. What is the ratio of the Balance of Payment (as % of service exports) of 2005 in Egypt, Arab Rep. to that in Estonia?
Offer a very short reply. 1.55. What is the ratio of the Balance of Payment (as % of service exports) of 2006 in Egypt, Arab Rep. to that in Estonia?
Your answer should be very brief. 1.62. What is the ratio of the Balance of Payment (as % of service exports) of 2007 in Egypt, Arab Rep. to that in Estonia?
Your response must be concise. 2.01. What is the ratio of the Balance of Payment (as % of service exports) in 2008 in Egypt, Arab Rep. to that in Estonia?
Give a very brief answer. 1.89. What is the ratio of the Balance of Payment (as % of service exports) of 2005 in El Salvador to that in Estonia?
Offer a very short reply. 0.81. What is the ratio of the Balance of Payment (as % of service exports) in 2006 in El Salvador to that in Estonia?
Make the answer very short. 0.87. What is the ratio of the Balance of Payment (as % of service exports) in 2007 in El Salvador to that in Estonia?
Your answer should be very brief. 1.33. What is the ratio of the Balance of Payment (as % of service exports) in 2008 in El Salvador to that in Estonia?
Give a very brief answer. 1.18. What is the difference between the highest and the second highest Balance of Payment (as % of service exports) of 2005?
Give a very brief answer. 0.88. What is the difference between the highest and the second highest Balance of Payment (as % of service exports) of 2006?
Make the answer very short. 4.94. What is the difference between the highest and the second highest Balance of Payment (as % of service exports) in 2007?
Offer a very short reply. 9.87. What is the difference between the highest and the second highest Balance of Payment (as % of service exports) of 2008?
Keep it short and to the point. 4.7. What is the difference between the highest and the lowest Balance of Payment (as % of service exports) of 2005?
Ensure brevity in your answer.  45.85. What is the difference between the highest and the lowest Balance of Payment (as % of service exports) in 2006?
Your response must be concise. 46.33. What is the difference between the highest and the lowest Balance of Payment (as % of service exports) of 2007?
Your answer should be compact. 46.47. What is the difference between the highest and the lowest Balance of Payment (as % of service exports) of 2008?
Your response must be concise. 44.01. 